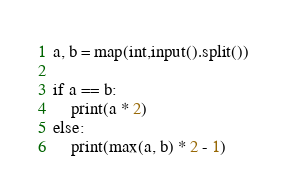<code> <loc_0><loc_0><loc_500><loc_500><_Python_>a, b = map(int,input().split())

if a == b:
    print(a * 2)
else:
    print(max(a, b) * 2 - 1)</code> 